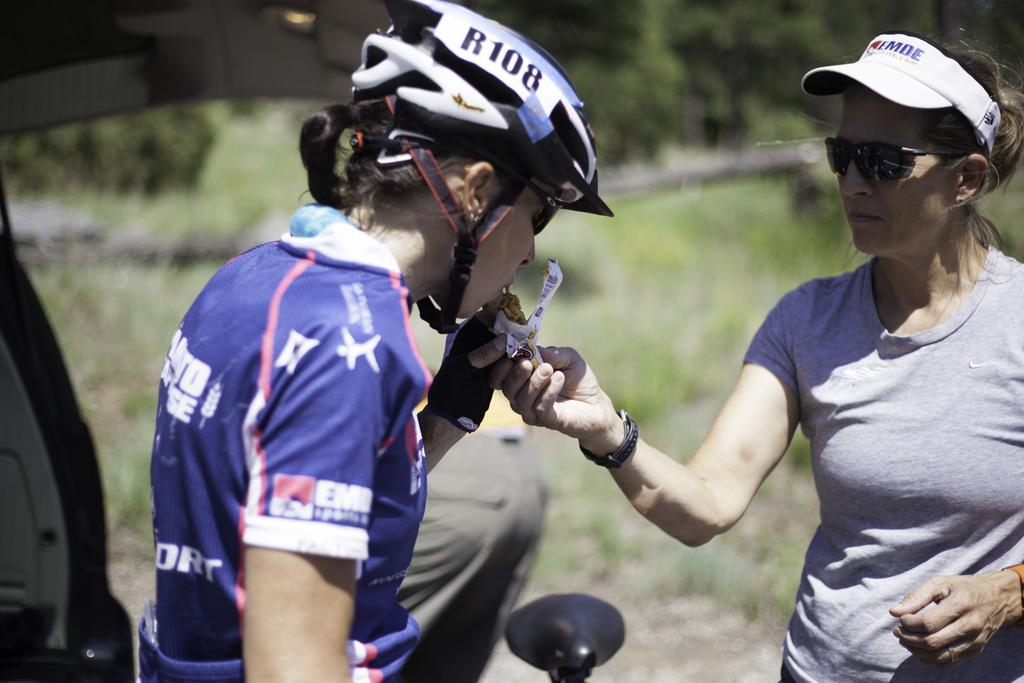What is happening on the right side of the image? There is a lady standing on the right side of the image, and she is feeding another lady standing next to her. Can you describe the background of the image? There is a vehicle and grass visible in the background of the image. How many horses can be seen in the image? There are no horses present in the image. What causes the lady to laugh in the image? There is no indication in the image that the lady is laughing, and no specific cause for laughter is depicted. 